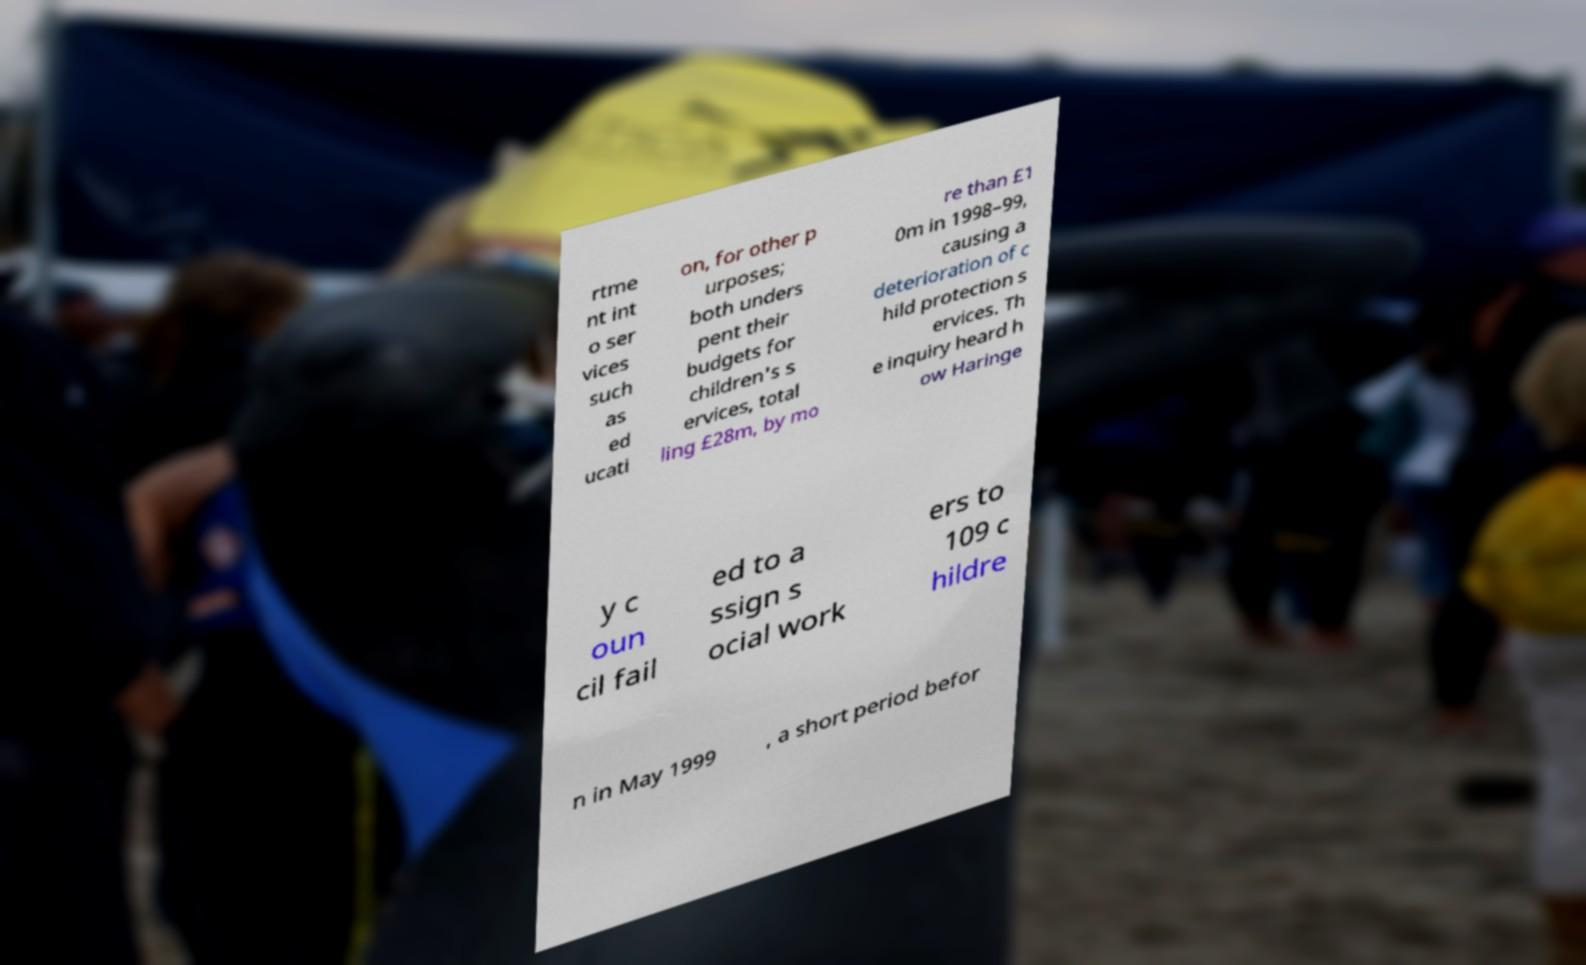For documentation purposes, I need the text within this image transcribed. Could you provide that? rtme nt int o ser vices such as ed ucati on, for other p urposes; both unders pent their budgets for children's s ervices, total ling £28m, by mo re than £1 0m in 1998–99, causing a deterioration of c hild protection s ervices. Th e inquiry heard h ow Haringe y c oun cil fail ed to a ssign s ocial work ers to 109 c hildre n in May 1999 , a short period befor 